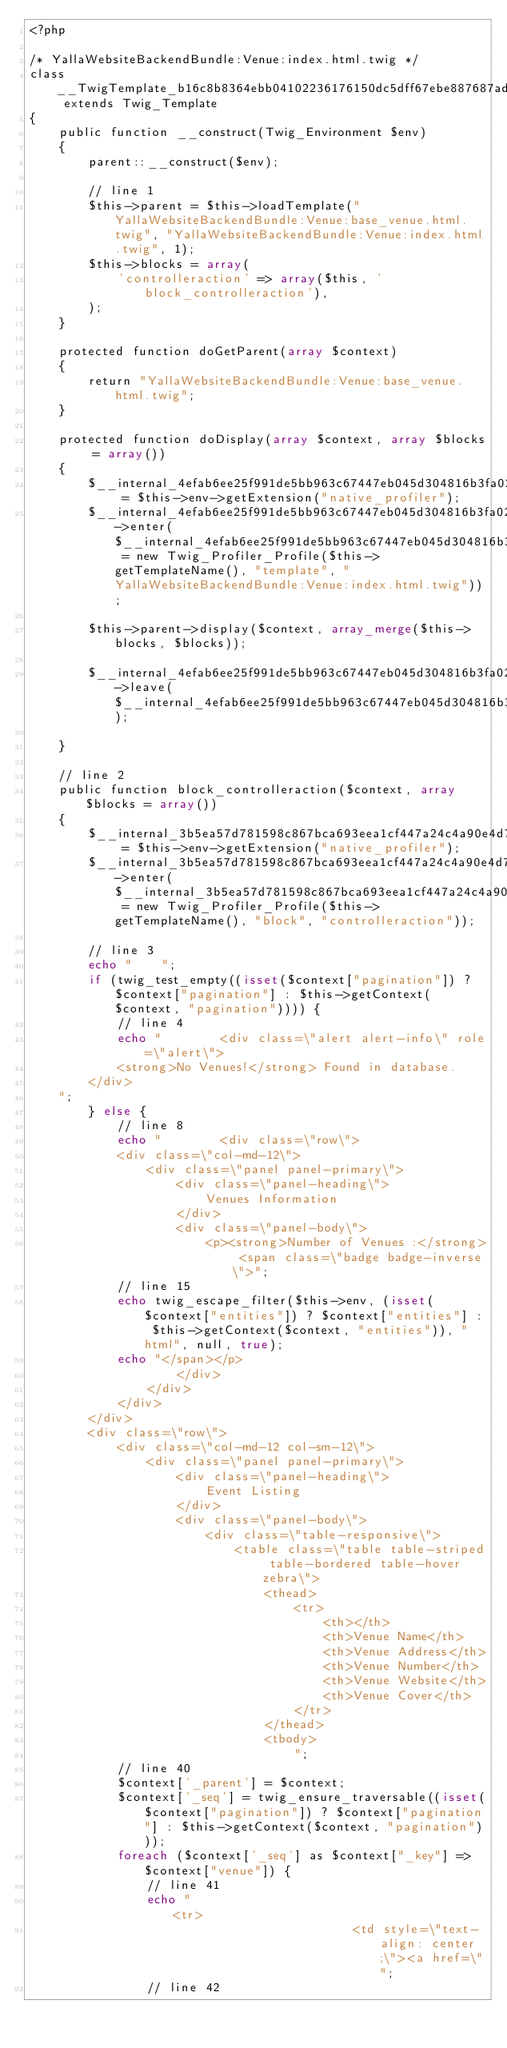<code> <loc_0><loc_0><loc_500><loc_500><_PHP_><?php

/* YallaWebsiteBackendBundle:Venue:index.html.twig */
class __TwigTemplate_b16c8b8364ebb04102236176150dc5dff67ebe887687adc0a5f69de330765ed0 extends Twig_Template
{
    public function __construct(Twig_Environment $env)
    {
        parent::__construct($env);

        // line 1
        $this->parent = $this->loadTemplate("YallaWebsiteBackendBundle:Venue:base_venue.html.twig", "YallaWebsiteBackendBundle:Venue:index.html.twig", 1);
        $this->blocks = array(
            'controlleraction' => array($this, 'block_controlleraction'),
        );
    }

    protected function doGetParent(array $context)
    {
        return "YallaWebsiteBackendBundle:Venue:base_venue.html.twig";
    }

    protected function doDisplay(array $context, array $blocks = array())
    {
        $__internal_4efab6ee25f991de5bb963c67447eb045d304816b3fa028119095165bd16a876 = $this->env->getExtension("native_profiler");
        $__internal_4efab6ee25f991de5bb963c67447eb045d304816b3fa028119095165bd16a876->enter($__internal_4efab6ee25f991de5bb963c67447eb045d304816b3fa028119095165bd16a876_prof = new Twig_Profiler_Profile($this->getTemplateName(), "template", "YallaWebsiteBackendBundle:Venue:index.html.twig"));

        $this->parent->display($context, array_merge($this->blocks, $blocks));
        
        $__internal_4efab6ee25f991de5bb963c67447eb045d304816b3fa028119095165bd16a876->leave($__internal_4efab6ee25f991de5bb963c67447eb045d304816b3fa028119095165bd16a876_prof);

    }

    // line 2
    public function block_controlleraction($context, array $blocks = array())
    {
        $__internal_3b5ea57d781598c867bca693eea1cf447a24c4a90e4d7f60962d9b812f56cfc0 = $this->env->getExtension("native_profiler");
        $__internal_3b5ea57d781598c867bca693eea1cf447a24c4a90e4d7f60962d9b812f56cfc0->enter($__internal_3b5ea57d781598c867bca693eea1cf447a24c4a90e4d7f60962d9b812f56cfc0_prof = new Twig_Profiler_Profile($this->getTemplateName(), "block", "controlleraction"));

        // line 3
        echo "    ";
        if (twig_test_empty((isset($context["pagination"]) ? $context["pagination"] : $this->getContext($context, "pagination")))) {
            // line 4
            echo "        <div class=\"alert alert-info\" role=\"alert\">
            <strong>No Venues!</strong> Found in database.
        </div>
    ";
        } else {
            // line 8
            echo "        <div class=\"row\">
            <div class=\"col-md-12\">
                <div class=\"panel panel-primary\">
                    <div class=\"panel-heading\">
                        Venues Information
                    </div>
                    <div class=\"panel-body\">
                        <p><strong>Number of Venues :</strong> <span class=\"badge badge-inverse\">";
            // line 15
            echo twig_escape_filter($this->env, (isset($context["entities"]) ? $context["entities"] : $this->getContext($context, "entities")), "html", null, true);
            echo "</span></p>
                    </div>
                </div>
            </div>
        </div>
        <div class=\"row\">
            <div class=\"col-md-12 col-sm-12\">
                <div class=\"panel panel-primary\">
                    <div class=\"panel-heading\">
                        Event Listing
                    </div>
                    <div class=\"panel-body\">
                        <div class=\"table-responsive\">
                            <table class=\"table table-striped table-bordered table-hover zebra\">
                                <thead>
                                    <tr>
                                        <th></th>                                        
                                        <th>Venue Name</th>
                                        <th>Venue Address</th>
                                        <th>Venue Number</th>
                                        <th>Venue Website</th>
                                        <th>Venue Cover</th>
                                    </tr>
                                </thead>
                                <tbody>
                                    ";
            // line 40
            $context['_parent'] = $context;
            $context['_seq'] = twig_ensure_traversable((isset($context["pagination"]) ? $context["pagination"] : $this->getContext($context, "pagination")));
            foreach ($context['_seq'] as $context["_key"] => $context["venue"]) {
                // line 41
                echo "                                        <tr>
                                            <td style=\"text-align: center;\"><a href=\"";
                // line 42</code> 